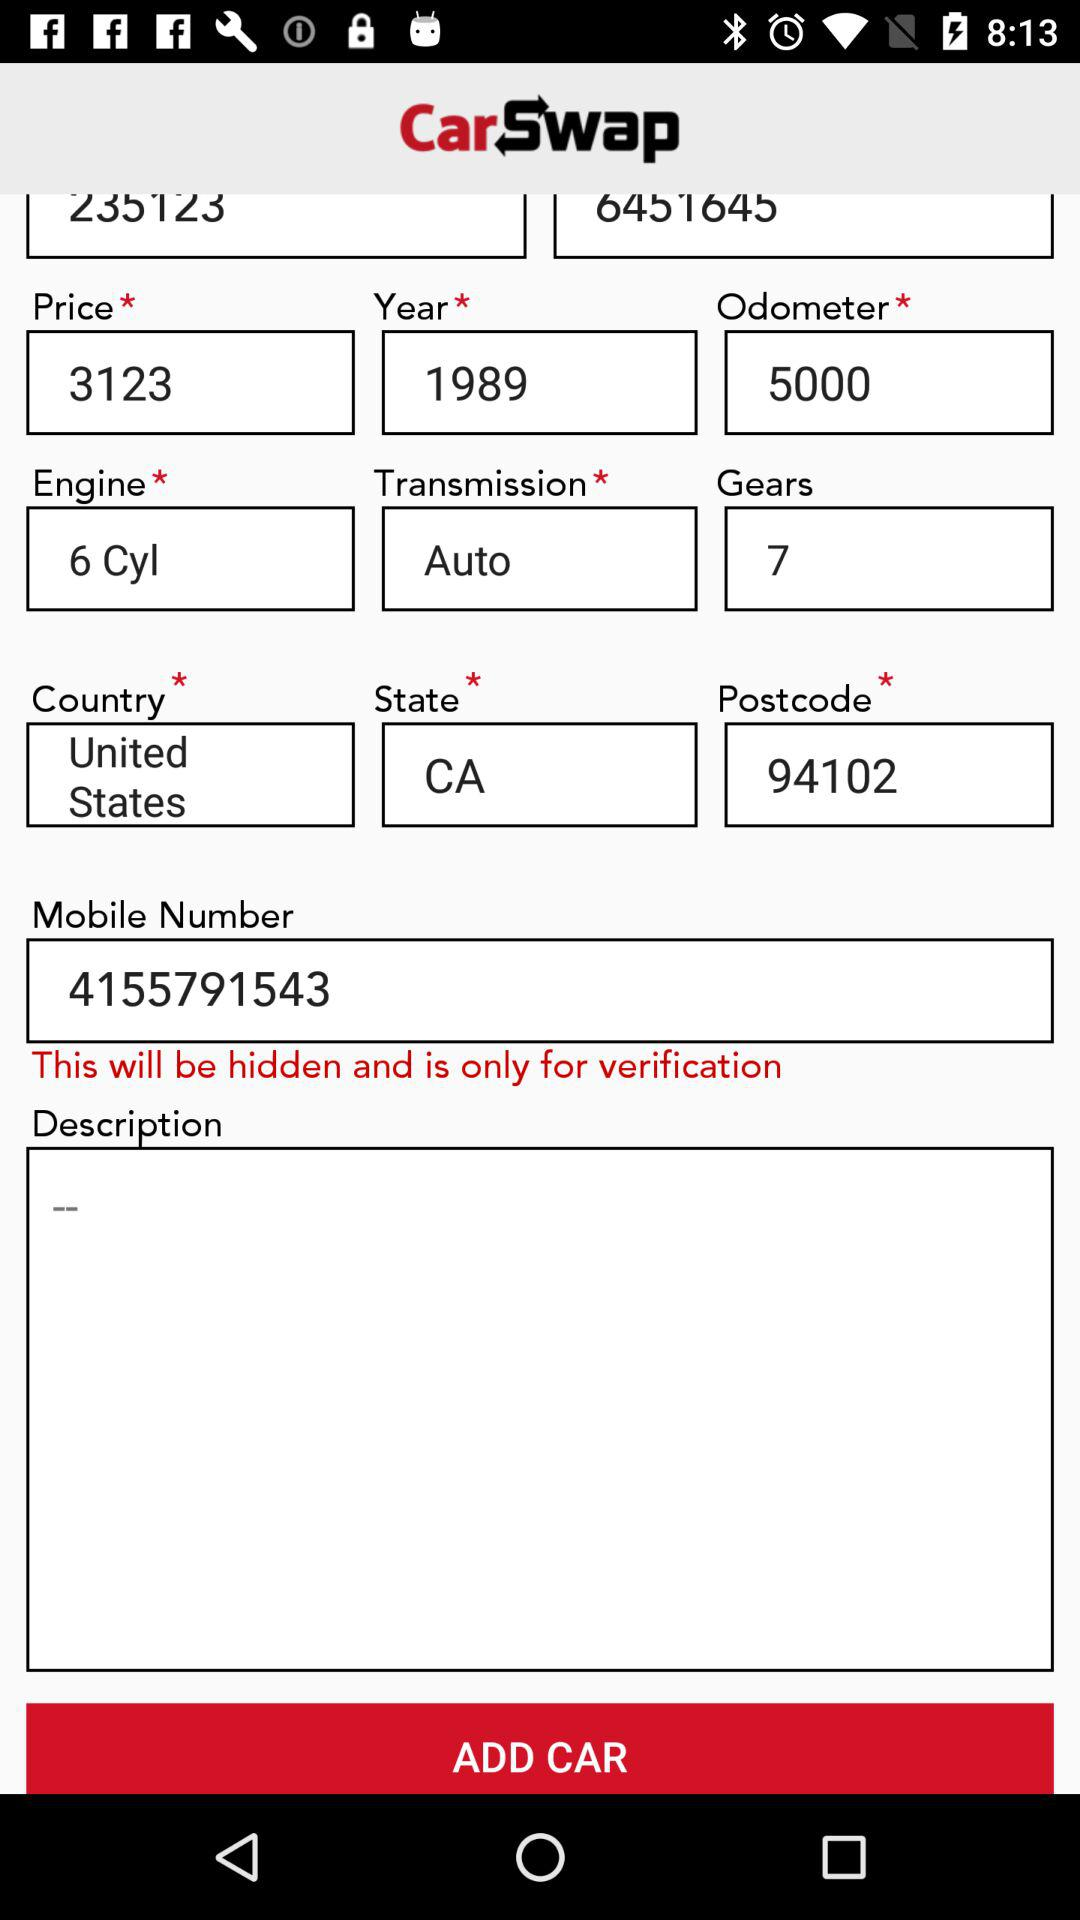What is the transmission? The transmission is auto. 